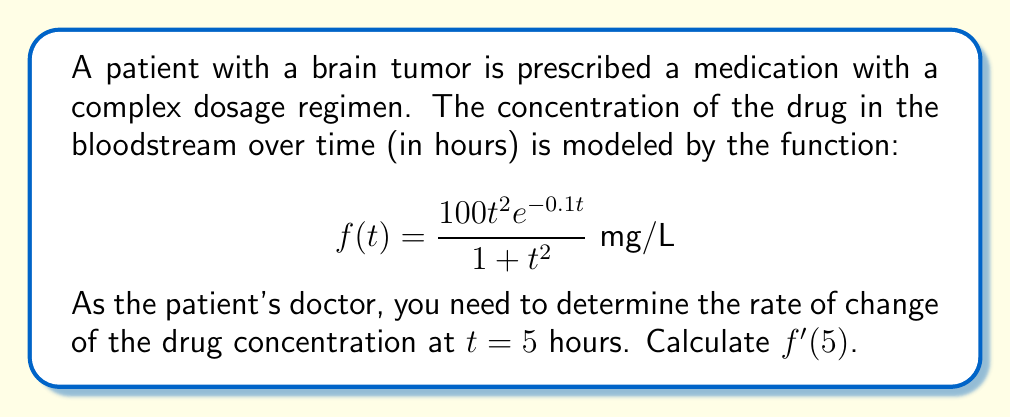Give your solution to this math problem. To find $f'(5)$, we need to calculate the derivative of $f(t)$ and then evaluate it at t = 5. Let's break this down step-by-step:

1) First, let's use the quotient rule to differentiate $f(t)$. If we let $u(t) = 100t^2e^{-0.1t}$ and $v(t) = 1+t^2$, then:

   $$f'(t) = \frac{u'(t)v(t) - u(t)v'(t)}{[v(t)]^2}$$

2) Now we need to find $u'(t)$ and $v'(t)$:

   For $u'(t)$, we use the product rule:
   $$u'(t) = 100(2te^{-0.1t} + t^2(-0.1)e^{-0.1t}) = 100e^{-0.1t}(2t - 0.1t^2)$$

   For $v'(t)$:
   $$v'(t) = 2t$$

3) Substituting these back into the quotient rule:

   $$f'(t) = \frac{100e^{-0.1t}(2t - 0.1t^2)(1+t^2) - 100t^2e^{-0.1t}(2t)}{(1+t^2)^2}$$

4) Simplifying the numerator:

   $$f'(t) = \frac{100e^{-0.1t}[(2t - 0.1t^2)(1+t^2) - 2t^3]}{(1+t^2)^2}$$
   $$= \frac{100e^{-0.1t}[2t + 2t^3 - 0.1t^2 - 0.1t^4 - 2t^3]}{(1+t^2)^2}$$
   $$= \frac{100e^{-0.1t}[2t - 0.1t^2 - 0.1t^4]}{(1+t^2)^2}$$

5) Now we can evaluate this at t = 5:

   $$f'(5) = \frac{100e^{-0.5}[2(5) - 0.1(5)^2 - 0.1(5)^4]}{(1+5^2)^2}$$
   $$= \frac{100e^{-0.5}[10 - 2.5 - 62.5]}{36^2}$$
   $$= \frac{100e^{-0.5}(-55)}{1296}$$
   $$\approx -3.36 \text{ mg/L/hour}$$
Answer: $f'(5) \approx -3.36 \text{ mg/L/hour}$ 